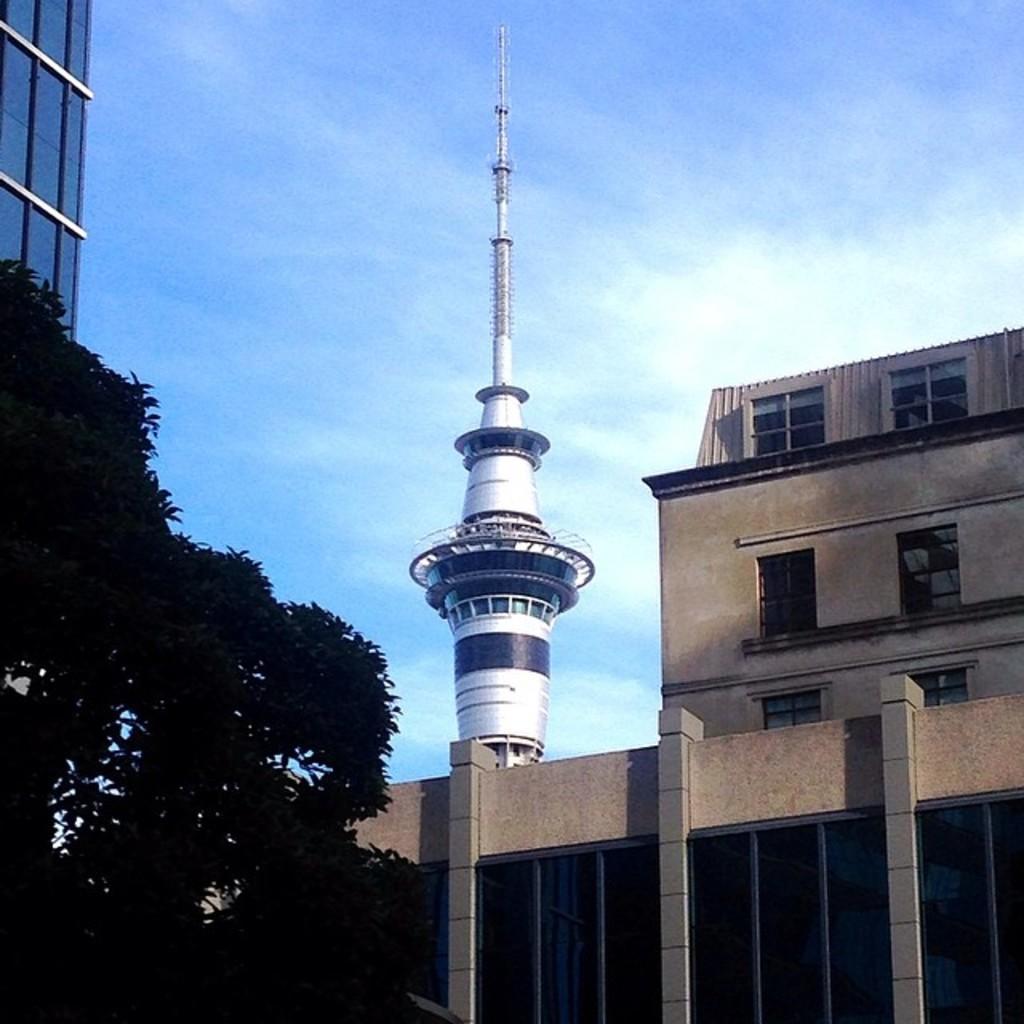Describe this image in one or two sentences. On the left side, there are trees and there is a building which is having glass windows. On the right side, there are buildings which are having windows and there is a tower. In the background, there are clouds in the blue sky. 